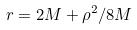Convert formula to latex. <formula><loc_0><loc_0><loc_500><loc_500>r = 2 M + \rho ^ { 2 } / 8 M</formula> 